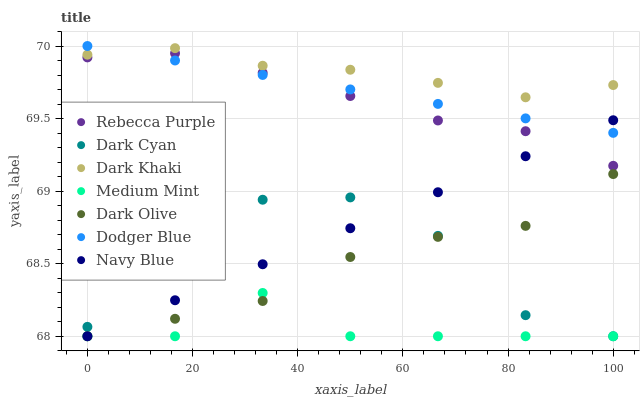Does Medium Mint have the minimum area under the curve?
Answer yes or no. Yes. Does Dark Khaki have the maximum area under the curve?
Answer yes or no. Yes. Does Navy Blue have the minimum area under the curve?
Answer yes or no. No. Does Navy Blue have the maximum area under the curve?
Answer yes or no. No. Is Dodger Blue the smoothest?
Answer yes or no. Yes. Is Dark Cyan the roughest?
Answer yes or no. Yes. Is Navy Blue the smoothest?
Answer yes or no. No. Is Navy Blue the roughest?
Answer yes or no. No. Does Medium Mint have the lowest value?
Answer yes or no. Yes. Does Dark Khaki have the lowest value?
Answer yes or no. No. Does Dodger Blue have the highest value?
Answer yes or no. Yes. Does Navy Blue have the highest value?
Answer yes or no. No. Is Dark Olive less than Dodger Blue?
Answer yes or no. Yes. Is Dodger Blue greater than Dark Olive?
Answer yes or no. Yes. Does Dodger Blue intersect Dark Khaki?
Answer yes or no. Yes. Is Dodger Blue less than Dark Khaki?
Answer yes or no. No. Is Dodger Blue greater than Dark Khaki?
Answer yes or no. No. Does Dark Olive intersect Dodger Blue?
Answer yes or no. No. 